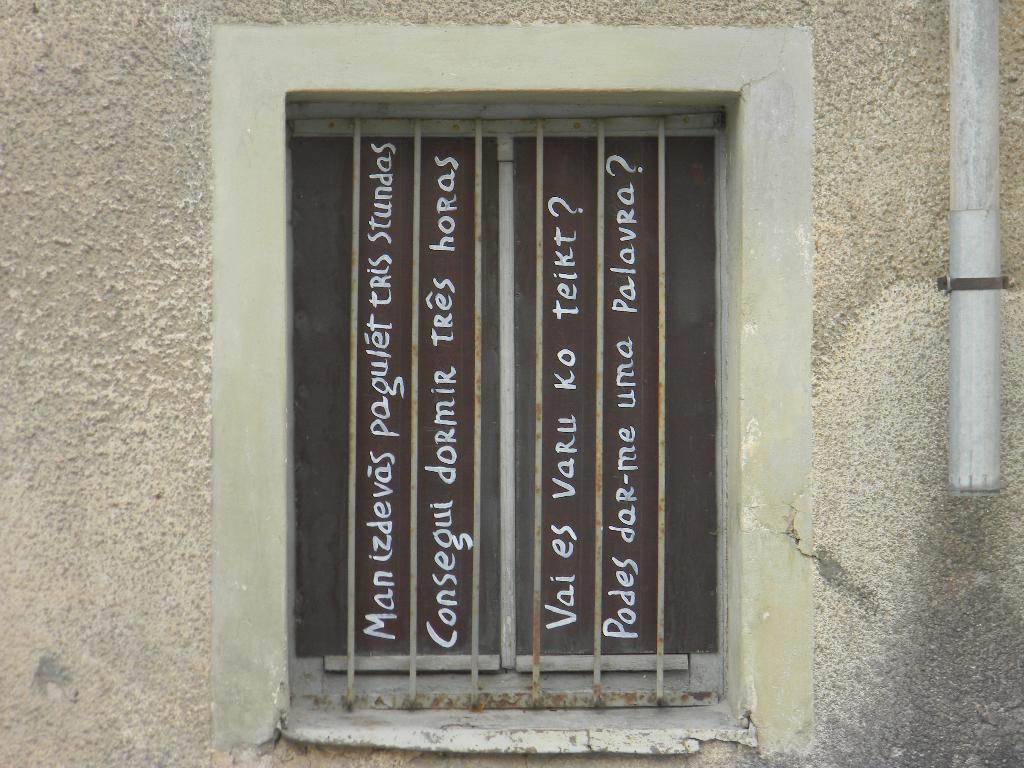Please provide a concise description of this image. In the image it seems to be a window in the middle of the wall with some text on it. 